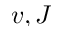<formula> <loc_0><loc_0><loc_500><loc_500>v , J</formula> 